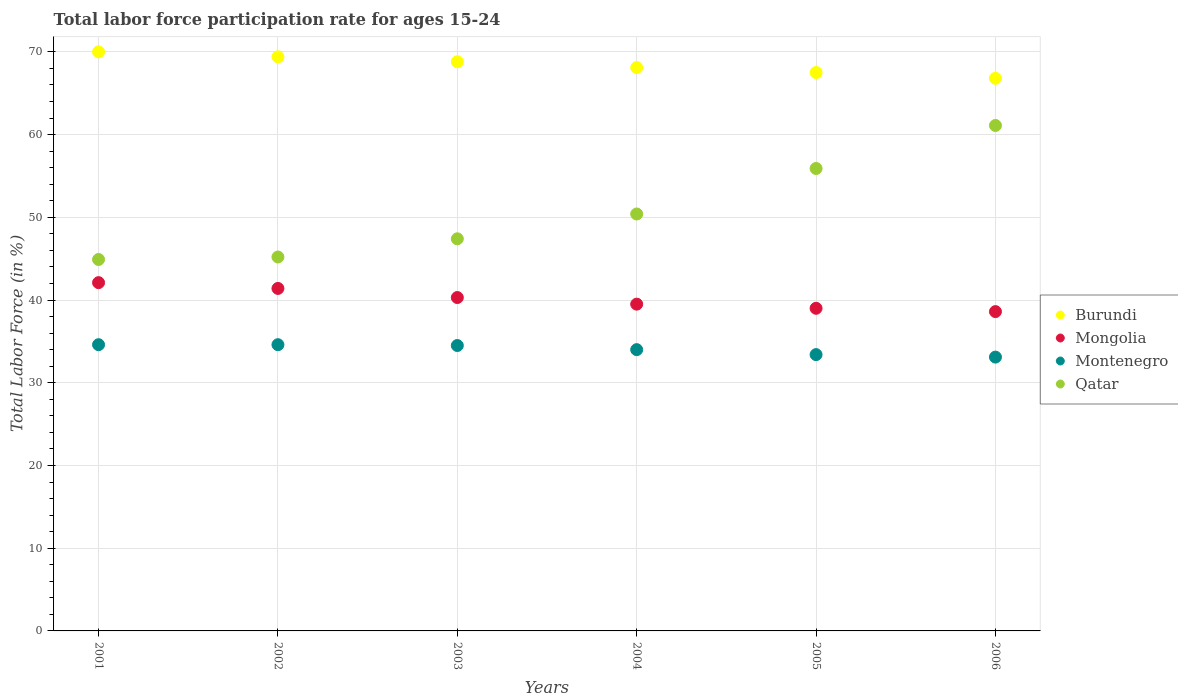How many different coloured dotlines are there?
Provide a succinct answer. 4. Across all years, what is the maximum labor force participation rate in Mongolia?
Keep it short and to the point. 42.1. Across all years, what is the minimum labor force participation rate in Qatar?
Your answer should be very brief. 44.9. What is the total labor force participation rate in Burundi in the graph?
Make the answer very short. 410.6. What is the difference between the labor force participation rate in Burundi in 2003 and that in 2004?
Keep it short and to the point. 0.7. What is the difference between the labor force participation rate in Burundi in 2003 and the labor force participation rate in Qatar in 2005?
Provide a short and direct response. 12.9. What is the average labor force participation rate in Montenegro per year?
Make the answer very short. 34.03. In the year 2005, what is the difference between the labor force participation rate in Qatar and labor force participation rate in Burundi?
Ensure brevity in your answer.  -11.6. What is the ratio of the labor force participation rate in Burundi in 2001 to that in 2005?
Ensure brevity in your answer.  1.04. Is the labor force participation rate in Montenegro in 2002 less than that in 2004?
Provide a succinct answer. No. What is the difference between the highest and the second highest labor force participation rate in Mongolia?
Provide a short and direct response. 0.7. In how many years, is the labor force participation rate in Mongolia greater than the average labor force participation rate in Mongolia taken over all years?
Provide a succinct answer. 3. Is the sum of the labor force participation rate in Mongolia in 2002 and 2005 greater than the maximum labor force participation rate in Qatar across all years?
Your response must be concise. Yes. Is the labor force participation rate in Qatar strictly greater than the labor force participation rate in Montenegro over the years?
Your response must be concise. Yes. How many years are there in the graph?
Give a very brief answer. 6. Are the values on the major ticks of Y-axis written in scientific E-notation?
Keep it short and to the point. No. Does the graph contain grids?
Keep it short and to the point. Yes. What is the title of the graph?
Ensure brevity in your answer.  Total labor force participation rate for ages 15-24. Does "Uzbekistan" appear as one of the legend labels in the graph?
Your response must be concise. No. What is the label or title of the X-axis?
Make the answer very short. Years. What is the Total Labor Force (in %) in Mongolia in 2001?
Make the answer very short. 42.1. What is the Total Labor Force (in %) of Montenegro in 2001?
Your response must be concise. 34.6. What is the Total Labor Force (in %) of Qatar in 2001?
Your response must be concise. 44.9. What is the Total Labor Force (in %) of Burundi in 2002?
Offer a terse response. 69.4. What is the Total Labor Force (in %) in Mongolia in 2002?
Your response must be concise. 41.4. What is the Total Labor Force (in %) in Montenegro in 2002?
Your answer should be compact. 34.6. What is the Total Labor Force (in %) in Qatar in 2002?
Give a very brief answer. 45.2. What is the Total Labor Force (in %) of Burundi in 2003?
Keep it short and to the point. 68.8. What is the Total Labor Force (in %) of Mongolia in 2003?
Your answer should be compact. 40.3. What is the Total Labor Force (in %) in Montenegro in 2003?
Offer a very short reply. 34.5. What is the Total Labor Force (in %) in Qatar in 2003?
Offer a very short reply. 47.4. What is the Total Labor Force (in %) in Burundi in 2004?
Offer a very short reply. 68.1. What is the Total Labor Force (in %) of Mongolia in 2004?
Your response must be concise. 39.5. What is the Total Labor Force (in %) in Montenegro in 2004?
Provide a short and direct response. 34. What is the Total Labor Force (in %) in Qatar in 2004?
Offer a terse response. 50.4. What is the Total Labor Force (in %) in Burundi in 2005?
Your response must be concise. 67.5. What is the Total Labor Force (in %) in Mongolia in 2005?
Your answer should be very brief. 39. What is the Total Labor Force (in %) of Montenegro in 2005?
Your answer should be very brief. 33.4. What is the Total Labor Force (in %) of Qatar in 2005?
Provide a succinct answer. 55.9. What is the Total Labor Force (in %) of Burundi in 2006?
Provide a succinct answer. 66.8. What is the Total Labor Force (in %) in Mongolia in 2006?
Keep it short and to the point. 38.6. What is the Total Labor Force (in %) in Montenegro in 2006?
Keep it short and to the point. 33.1. What is the Total Labor Force (in %) in Qatar in 2006?
Your response must be concise. 61.1. Across all years, what is the maximum Total Labor Force (in %) in Mongolia?
Your answer should be compact. 42.1. Across all years, what is the maximum Total Labor Force (in %) of Montenegro?
Keep it short and to the point. 34.6. Across all years, what is the maximum Total Labor Force (in %) of Qatar?
Give a very brief answer. 61.1. Across all years, what is the minimum Total Labor Force (in %) of Burundi?
Your response must be concise. 66.8. Across all years, what is the minimum Total Labor Force (in %) in Mongolia?
Keep it short and to the point. 38.6. Across all years, what is the minimum Total Labor Force (in %) of Montenegro?
Your answer should be very brief. 33.1. Across all years, what is the minimum Total Labor Force (in %) in Qatar?
Give a very brief answer. 44.9. What is the total Total Labor Force (in %) in Burundi in the graph?
Your answer should be very brief. 410.6. What is the total Total Labor Force (in %) in Mongolia in the graph?
Ensure brevity in your answer.  240.9. What is the total Total Labor Force (in %) in Montenegro in the graph?
Your response must be concise. 204.2. What is the total Total Labor Force (in %) in Qatar in the graph?
Offer a terse response. 304.9. What is the difference between the Total Labor Force (in %) of Qatar in 2001 and that in 2002?
Your answer should be very brief. -0.3. What is the difference between the Total Labor Force (in %) in Montenegro in 2001 and that in 2003?
Make the answer very short. 0.1. What is the difference between the Total Labor Force (in %) of Burundi in 2001 and that in 2004?
Your response must be concise. 1.9. What is the difference between the Total Labor Force (in %) in Mongolia in 2001 and that in 2004?
Your answer should be compact. 2.6. What is the difference between the Total Labor Force (in %) in Qatar in 2001 and that in 2004?
Ensure brevity in your answer.  -5.5. What is the difference between the Total Labor Force (in %) of Mongolia in 2001 and that in 2005?
Provide a succinct answer. 3.1. What is the difference between the Total Labor Force (in %) of Montenegro in 2001 and that in 2005?
Keep it short and to the point. 1.2. What is the difference between the Total Labor Force (in %) of Qatar in 2001 and that in 2005?
Provide a short and direct response. -11. What is the difference between the Total Labor Force (in %) in Burundi in 2001 and that in 2006?
Provide a succinct answer. 3.2. What is the difference between the Total Labor Force (in %) of Qatar in 2001 and that in 2006?
Give a very brief answer. -16.2. What is the difference between the Total Labor Force (in %) of Montenegro in 2002 and that in 2003?
Your response must be concise. 0.1. What is the difference between the Total Labor Force (in %) in Qatar in 2002 and that in 2003?
Your response must be concise. -2.2. What is the difference between the Total Labor Force (in %) of Montenegro in 2002 and that in 2004?
Ensure brevity in your answer.  0.6. What is the difference between the Total Labor Force (in %) of Burundi in 2002 and that in 2005?
Provide a short and direct response. 1.9. What is the difference between the Total Labor Force (in %) of Montenegro in 2002 and that in 2005?
Your answer should be very brief. 1.2. What is the difference between the Total Labor Force (in %) in Qatar in 2002 and that in 2005?
Your answer should be very brief. -10.7. What is the difference between the Total Labor Force (in %) in Burundi in 2002 and that in 2006?
Your answer should be compact. 2.6. What is the difference between the Total Labor Force (in %) in Mongolia in 2002 and that in 2006?
Give a very brief answer. 2.8. What is the difference between the Total Labor Force (in %) of Montenegro in 2002 and that in 2006?
Give a very brief answer. 1.5. What is the difference between the Total Labor Force (in %) in Qatar in 2002 and that in 2006?
Offer a very short reply. -15.9. What is the difference between the Total Labor Force (in %) in Mongolia in 2003 and that in 2004?
Keep it short and to the point. 0.8. What is the difference between the Total Labor Force (in %) of Montenegro in 2003 and that in 2004?
Offer a terse response. 0.5. What is the difference between the Total Labor Force (in %) in Qatar in 2003 and that in 2004?
Give a very brief answer. -3. What is the difference between the Total Labor Force (in %) in Mongolia in 2003 and that in 2005?
Your answer should be compact. 1.3. What is the difference between the Total Labor Force (in %) of Montenegro in 2003 and that in 2005?
Give a very brief answer. 1.1. What is the difference between the Total Labor Force (in %) in Qatar in 2003 and that in 2005?
Provide a short and direct response. -8.5. What is the difference between the Total Labor Force (in %) of Burundi in 2003 and that in 2006?
Offer a very short reply. 2. What is the difference between the Total Labor Force (in %) of Qatar in 2003 and that in 2006?
Your response must be concise. -13.7. What is the difference between the Total Labor Force (in %) of Mongolia in 2004 and that in 2005?
Keep it short and to the point. 0.5. What is the difference between the Total Labor Force (in %) in Montenegro in 2004 and that in 2005?
Your response must be concise. 0.6. What is the difference between the Total Labor Force (in %) in Qatar in 2004 and that in 2005?
Provide a succinct answer. -5.5. What is the difference between the Total Labor Force (in %) of Burundi in 2004 and that in 2006?
Keep it short and to the point. 1.3. What is the difference between the Total Labor Force (in %) in Mongolia in 2004 and that in 2006?
Your response must be concise. 0.9. What is the difference between the Total Labor Force (in %) in Montenegro in 2004 and that in 2006?
Provide a short and direct response. 0.9. What is the difference between the Total Labor Force (in %) of Qatar in 2004 and that in 2006?
Keep it short and to the point. -10.7. What is the difference between the Total Labor Force (in %) in Mongolia in 2005 and that in 2006?
Make the answer very short. 0.4. What is the difference between the Total Labor Force (in %) of Burundi in 2001 and the Total Labor Force (in %) of Mongolia in 2002?
Offer a very short reply. 28.6. What is the difference between the Total Labor Force (in %) in Burundi in 2001 and the Total Labor Force (in %) in Montenegro in 2002?
Provide a short and direct response. 35.4. What is the difference between the Total Labor Force (in %) in Burundi in 2001 and the Total Labor Force (in %) in Qatar in 2002?
Provide a succinct answer. 24.8. What is the difference between the Total Labor Force (in %) in Burundi in 2001 and the Total Labor Force (in %) in Mongolia in 2003?
Give a very brief answer. 29.7. What is the difference between the Total Labor Force (in %) of Burundi in 2001 and the Total Labor Force (in %) of Montenegro in 2003?
Give a very brief answer. 35.5. What is the difference between the Total Labor Force (in %) in Burundi in 2001 and the Total Labor Force (in %) in Qatar in 2003?
Make the answer very short. 22.6. What is the difference between the Total Labor Force (in %) of Burundi in 2001 and the Total Labor Force (in %) of Mongolia in 2004?
Make the answer very short. 30.5. What is the difference between the Total Labor Force (in %) of Burundi in 2001 and the Total Labor Force (in %) of Qatar in 2004?
Ensure brevity in your answer.  19.6. What is the difference between the Total Labor Force (in %) of Mongolia in 2001 and the Total Labor Force (in %) of Qatar in 2004?
Your response must be concise. -8.3. What is the difference between the Total Labor Force (in %) in Montenegro in 2001 and the Total Labor Force (in %) in Qatar in 2004?
Provide a short and direct response. -15.8. What is the difference between the Total Labor Force (in %) of Burundi in 2001 and the Total Labor Force (in %) of Montenegro in 2005?
Your answer should be compact. 36.6. What is the difference between the Total Labor Force (in %) of Montenegro in 2001 and the Total Labor Force (in %) of Qatar in 2005?
Give a very brief answer. -21.3. What is the difference between the Total Labor Force (in %) in Burundi in 2001 and the Total Labor Force (in %) in Mongolia in 2006?
Provide a succinct answer. 31.4. What is the difference between the Total Labor Force (in %) in Burundi in 2001 and the Total Labor Force (in %) in Montenegro in 2006?
Provide a short and direct response. 36.9. What is the difference between the Total Labor Force (in %) of Mongolia in 2001 and the Total Labor Force (in %) of Montenegro in 2006?
Provide a succinct answer. 9. What is the difference between the Total Labor Force (in %) of Mongolia in 2001 and the Total Labor Force (in %) of Qatar in 2006?
Give a very brief answer. -19. What is the difference between the Total Labor Force (in %) of Montenegro in 2001 and the Total Labor Force (in %) of Qatar in 2006?
Make the answer very short. -26.5. What is the difference between the Total Labor Force (in %) of Burundi in 2002 and the Total Labor Force (in %) of Mongolia in 2003?
Your answer should be very brief. 29.1. What is the difference between the Total Labor Force (in %) of Burundi in 2002 and the Total Labor Force (in %) of Montenegro in 2003?
Your answer should be very brief. 34.9. What is the difference between the Total Labor Force (in %) in Mongolia in 2002 and the Total Labor Force (in %) in Qatar in 2003?
Offer a very short reply. -6. What is the difference between the Total Labor Force (in %) in Burundi in 2002 and the Total Labor Force (in %) in Mongolia in 2004?
Provide a short and direct response. 29.9. What is the difference between the Total Labor Force (in %) in Burundi in 2002 and the Total Labor Force (in %) in Montenegro in 2004?
Offer a terse response. 35.4. What is the difference between the Total Labor Force (in %) of Mongolia in 2002 and the Total Labor Force (in %) of Montenegro in 2004?
Your answer should be very brief. 7.4. What is the difference between the Total Labor Force (in %) in Montenegro in 2002 and the Total Labor Force (in %) in Qatar in 2004?
Your response must be concise. -15.8. What is the difference between the Total Labor Force (in %) in Burundi in 2002 and the Total Labor Force (in %) in Mongolia in 2005?
Your response must be concise. 30.4. What is the difference between the Total Labor Force (in %) in Burundi in 2002 and the Total Labor Force (in %) in Montenegro in 2005?
Give a very brief answer. 36. What is the difference between the Total Labor Force (in %) in Burundi in 2002 and the Total Labor Force (in %) in Qatar in 2005?
Offer a very short reply. 13.5. What is the difference between the Total Labor Force (in %) of Mongolia in 2002 and the Total Labor Force (in %) of Montenegro in 2005?
Make the answer very short. 8. What is the difference between the Total Labor Force (in %) of Mongolia in 2002 and the Total Labor Force (in %) of Qatar in 2005?
Your response must be concise. -14.5. What is the difference between the Total Labor Force (in %) of Montenegro in 2002 and the Total Labor Force (in %) of Qatar in 2005?
Your answer should be very brief. -21.3. What is the difference between the Total Labor Force (in %) in Burundi in 2002 and the Total Labor Force (in %) in Mongolia in 2006?
Offer a very short reply. 30.8. What is the difference between the Total Labor Force (in %) in Burundi in 2002 and the Total Labor Force (in %) in Montenegro in 2006?
Ensure brevity in your answer.  36.3. What is the difference between the Total Labor Force (in %) in Burundi in 2002 and the Total Labor Force (in %) in Qatar in 2006?
Your response must be concise. 8.3. What is the difference between the Total Labor Force (in %) of Mongolia in 2002 and the Total Labor Force (in %) of Montenegro in 2006?
Provide a succinct answer. 8.3. What is the difference between the Total Labor Force (in %) in Mongolia in 2002 and the Total Labor Force (in %) in Qatar in 2006?
Provide a short and direct response. -19.7. What is the difference between the Total Labor Force (in %) of Montenegro in 2002 and the Total Labor Force (in %) of Qatar in 2006?
Offer a terse response. -26.5. What is the difference between the Total Labor Force (in %) in Burundi in 2003 and the Total Labor Force (in %) in Mongolia in 2004?
Your answer should be compact. 29.3. What is the difference between the Total Labor Force (in %) of Burundi in 2003 and the Total Labor Force (in %) of Montenegro in 2004?
Give a very brief answer. 34.8. What is the difference between the Total Labor Force (in %) of Burundi in 2003 and the Total Labor Force (in %) of Qatar in 2004?
Offer a very short reply. 18.4. What is the difference between the Total Labor Force (in %) of Mongolia in 2003 and the Total Labor Force (in %) of Montenegro in 2004?
Keep it short and to the point. 6.3. What is the difference between the Total Labor Force (in %) in Montenegro in 2003 and the Total Labor Force (in %) in Qatar in 2004?
Give a very brief answer. -15.9. What is the difference between the Total Labor Force (in %) in Burundi in 2003 and the Total Labor Force (in %) in Mongolia in 2005?
Your response must be concise. 29.8. What is the difference between the Total Labor Force (in %) of Burundi in 2003 and the Total Labor Force (in %) of Montenegro in 2005?
Offer a very short reply. 35.4. What is the difference between the Total Labor Force (in %) of Burundi in 2003 and the Total Labor Force (in %) of Qatar in 2005?
Provide a succinct answer. 12.9. What is the difference between the Total Labor Force (in %) in Mongolia in 2003 and the Total Labor Force (in %) in Qatar in 2005?
Give a very brief answer. -15.6. What is the difference between the Total Labor Force (in %) of Montenegro in 2003 and the Total Labor Force (in %) of Qatar in 2005?
Your answer should be compact. -21.4. What is the difference between the Total Labor Force (in %) of Burundi in 2003 and the Total Labor Force (in %) of Mongolia in 2006?
Provide a succinct answer. 30.2. What is the difference between the Total Labor Force (in %) of Burundi in 2003 and the Total Labor Force (in %) of Montenegro in 2006?
Give a very brief answer. 35.7. What is the difference between the Total Labor Force (in %) in Burundi in 2003 and the Total Labor Force (in %) in Qatar in 2006?
Provide a succinct answer. 7.7. What is the difference between the Total Labor Force (in %) of Mongolia in 2003 and the Total Labor Force (in %) of Qatar in 2006?
Your response must be concise. -20.8. What is the difference between the Total Labor Force (in %) in Montenegro in 2003 and the Total Labor Force (in %) in Qatar in 2006?
Your response must be concise. -26.6. What is the difference between the Total Labor Force (in %) in Burundi in 2004 and the Total Labor Force (in %) in Mongolia in 2005?
Keep it short and to the point. 29.1. What is the difference between the Total Labor Force (in %) in Burundi in 2004 and the Total Labor Force (in %) in Montenegro in 2005?
Keep it short and to the point. 34.7. What is the difference between the Total Labor Force (in %) in Burundi in 2004 and the Total Labor Force (in %) in Qatar in 2005?
Offer a terse response. 12.2. What is the difference between the Total Labor Force (in %) in Mongolia in 2004 and the Total Labor Force (in %) in Qatar in 2005?
Offer a terse response. -16.4. What is the difference between the Total Labor Force (in %) in Montenegro in 2004 and the Total Labor Force (in %) in Qatar in 2005?
Offer a terse response. -21.9. What is the difference between the Total Labor Force (in %) of Burundi in 2004 and the Total Labor Force (in %) of Mongolia in 2006?
Ensure brevity in your answer.  29.5. What is the difference between the Total Labor Force (in %) in Burundi in 2004 and the Total Labor Force (in %) in Qatar in 2006?
Your answer should be compact. 7. What is the difference between the Total Labor Force (in %) in Mongolia in 2004 and the Total Labor Force (in %) in Qatar in 2006?
Keep it short and to the point. -21.6. What is the difference between the Total Labor Force (in %) of Montenegro in 2004 and the Total Labor Force (in %) of Qatar in 2006?
Your answer should be compact. -27.1. What is the difference between the Total Labor Force (in %) of Burundi in 2005 and the Total Labor Force (in %) of Mongolia in 2006?
Keep it short and to the point. 28.9. What is the difference between the Total Labor Force (in %) of Burundi in 2005 and the Total Labor Force (in %) of Montenegro in 2006?
Make the answer very short. 34.4. What is the difference between the Total Labor Force (in %) of Mongolia in 2005 and the Total Labor Force (in %) of Montenegro in 2006?
Your response must be concise. 5.9. What is the difference between the Total Labor Force (in %) in Mongolia in 2005 and the Total Labor Force (in %) in Qatar in 2006?
Provide a succinct answer. -22.1. What is the difference between the Total Labor Force (in %) in Montenegro in 2005 and the Total Labor Force (in %) in Qatar in 2006?
Keep it short and to the point. -27.7. What is the average Total Labor Force (in %) of Burundi per year?
Offer a terse response. 68.43. What is the average Total Labor Force (in %) in Mongolia per year?
Provide a short and direct response. 40.15. What is the average Total Labor Force (in %) of Montenegro per year?
Offer a terse response. 34.03. What is the average Total Labor Force (in %) in Qatar per year?
Offer a very short reply. 50.82. In the year 2001, what is the difference between the Total Labor Force (in %) in Burundi and Total Labor Force (in %) in Mongolia?
Your answer should be very brief. 27.9. In the year 2001, what is the difference between the Total Labor Force (in %) of Burundi and Total Labor Force (in %) of Montenegro?
Give a very brief answer. 35.4. In the year 2001, what is the difference between the Total Labor Force (in %) of Burundi and Total Labor Force (in %) of Qatar?
Your answer should be compact. 25.1. In the year 2001, what is the difference between the Total Labor Force (in %) of Mongolia and Total Labor Force (in %) of Qatar?
Offer a very short reply. -2.8. In the year 2002, what is the difference between the Total Labor Force (in %) of Burundi and Total Labor Force (in %) of Mongolia?
Give a very brief answer. 28. In the year 2002, what is the difference between the Total Labor Force (in %) in Burundi and Total Labor Force (in %) in Montenegro?
Offer a very short reply. 34.8. In the year 2002, what is the difference between the Total Labor Force (in %) of Burundi and Total Labor Force (in %) of Qatar?
Your answer should be compact. 24.2. In the year 2002, what is the difference between the Total Labor Force (in %) in Mongolia and Total Labor Force (in %) in Montenegro?
Provide a succinct answer. 6.8. In the year 2003, what is the difference between the Total Labor Force (in %) in Burundi and Total Labor Force (in %) in Mongolia?
Provide a short and direct response. 28.5. In the year 2003, what is the difference between the Total Labor Force (in %) of Burundi and Total Labor Force (in %) of Montenegro?
Ensure brevity in your answer.  34.3. In the year 2003, what is the difference between the Total Labor Force (in %) of Burundi and Total Labor Force (in %) of Qatar?
Offer a very short reply. 21.4. In the year 2003, what is the difference between the Total Labor Force (in %) of Mongolia and Total Labor Force (in %) of Qatar?
Your response must be concise. -7.1. In the year 2004, what is the difference between the Total Labor Force (in %) in Burundi and Total Labor Force (in %) in Mongolia?
Keep it short and to the point. 28.6. In the year 2004, what is the difference between the Total Labor Force (in %) of Burundi and Total Labor Force (in %) of Montenegro?
Your answer should be very brief. 34.1. In the year 2004, what is the difference between the Total Labor Force (in %) of Mongolia and Total Labor Force (in %) of Qatar?
Make the answer very short. -10.9. In the year 2004, what is the difference between the Total Labor Force (in %) in Montenegro and Total Labor Force (in %) in Qatar?
Your answer should be very brief. -16.4. In the year 2005, what is the difference between the Total Labor Force (in %) of Burundi and Total Labor Force (in %) of Mongolia?
Give a very brief answer. 28.5. In the year 2005, what is the difference between the Total Labor Force (in %) of Burundi and Total Labor Force (in %) of Montenegro?
Give a very brief answer. 34.1. In the year 2005, what is the difference between the Total Labor Force (in %) in Mongolia and Total Labor Force (in %) in Montenegro?
Your answer should be compact. 5.6. In the year 2005, what is the difference between the Total Labor Force (in %) in Mongolia and Total Labor Force (in %) in Qatar?
Ensure brevity in your answer.  -16.9. In the year 2005, what is the difference between the Total Labor Force (in %) in Montenegro and Total Labor Force (in %) in Qatar?
Give a very brief answer. -22.5. In the year 2006, what is the difference between the Total Labor Force (in %) in Burundi and Total Labor Force (in %) in Mongolia?
Provide a succinct answer. 28.2. In the year 2006, what is the difference between the Total Labor Force (in %) in Burundi and Total Labor Force (in %) in Montenegro?
Ensure brevity in your answer.  33.7. In the year 2006, what is the difference between the Total Labor Force (in %) in Mongolia and Total Labor Force (in %) in Montenegro?
Provide a short and direct response. 5.5. In the year 2006, what is the difference between the Total Labor Force (in %) of Mongolia and Total Labor Force (in %) of Qatar?
Make the answer very short. -22.5. In the year 2006, what is the difference between the Total Labor Force (in %) of Montenegro and Total Labor Force (in %) of Qatar?
Offer a terse response. -28. What is the ratio of the Total Labor Force (in %) of Burundi in 2001 to that in 2002?
Your response must be concise. 1.01. What is the ratio of the Total Labor Force (in %) of Mongolia in 2001 to that in 2002?
Provide a short and direct response. 1.02. What is the ratio of the Total Labor Force (in %) of Burundi in 2001 to that in 2003?
Ensure brevity in your answer.  1.02. What is the ratio of the Total Labor Force (in %) in Mongolia in 2001 to that in 2003?
Your answer should be very brief. 1.04. What is the ratio of the Total Labor Force (in %) in Montenegro in 2001 to that in 2003?
Your answer should be compact. 1. What is the ratio of the Total Labor Force (in %) of Qatar in 2001 to that in 2003?
Offer a very short reply. 0.95. What is the ratio of the Total Labor Force (in %) of Burundi in 2001 to that in 2004?
Your answer should be very brief. 1.03. What is the ratio of the Total Labor Force (in %) in Mongolia in 2001 to that in 2004?
Provide a succinct answer. 1.07. What is the ratio of the Total Labor Force (in %) of Montenegro in 2001 to that in 2004?
Offer a very short reply. 1.02. What is the ratio of the Total Labor Force (in %) of Qatar in 2001 to that in 2004?
Offer a very short reply. 0.89. What is the ratio of the Total Labor Force (in %) of Burundi in 2001 to that in 2005?
Offer a very short reply. 1.04. What is the ratio of the Total Labor Force (in %) in Mongolia in 2001 to that in 2005?
Your response must be concise. 1.08. What is the ratio of the Total Labor Force (in %) in Montenegro in 2001 to that in 2005?
Offer a terse response. 1.04. What is the ratio of the Total Labor Force (in %) in Qatar in 2001 to that in 2005?
Your answer should be very brief. 0.8. What is the ratio of the Total Labor Force (in %) of Burundi in 2001 to that in 2006?
Your answer should be compact. 1.05. What is the ratio of the Total Labor Force (in %) in Mongolia in 2001 to that in 2006?
Provide a short and direct response. 1.09. What is the ratio of the Total Labor Force (in %) of Montenegro in 2001 to that in 2006?
Your answer should be compact. 1.05. What is the ratio of the Total Labor Force (in %) of Qatar in 2001 to that in 2006?
Make the answer very short. 0.73. What is the ratio of the Total Labor Force (in %) in Burundi in 2002 to that in 2003?
Offer a terse response. 1.01. What is the ratio of the Total Labor Force (in %) in Mongolia in 2002 to that in 2003?
Offer a terse response. 1.03. What is the ratio of the Total Labor Force (in %) of Montenegro in 2002 to that in 2003?
Ensure brevity in your answer.  1. What is the ratio of the Total Labor Force (in %) of Qatar in 2002 to that in 2003?
Your answer should be very brief. 0.95. What is the ratio of the Total Labor Force (in %) of Burundi in 2002 to that in 2004?
Provide a succinct answer. 1.02. What is the ratio of the Total Labor Force (in %) in Mongolia in 2002 to that in 2004?
Ensure brevity in your answer.  1.05. What is the ratio of the Total Labor Force (in %) in Montenegro in 2002 to that in 2004?
Provide a succinct answer. 1.02. What is the ratio of the Total Labor Force (in %) in Qatar in 2002 to that in 2004?
Provide a succinct answer. 0.9. What is the ratio of the Total Labor Force (in %) in Burundi in 2002 to that in 2005?
Provide a short and direct response. 1.03. What is the ratio of the Total Labor Force (in %) in Mongolia in 2002 to that in 2005?
Offer a very short reply. 1.06. What is the ratio of the Total Labor Force (in %) in Montenegro in 2002 to that in 2005?
Offer a very short reply. 1.04. What is the ratio of the Total Labor Force (in %) of Qatar in 2002 to that in 2005?
Offer a very short reply. 0.81. What is the ratio of the Total Labor Force (in %) of Burundi in 2002 to that in 2006?
Ensure brevity in your answer.  1.04. What is the ratio of the Total Labor Force (in %) of Mongolia in 2002 to that in 2006?
Provide a succinct answer. 1.07. What is the ratio of the Total Labor Force (in %) in Montenegro in 2002 to that in 2006?
Provide a short and direct response. 1.05. What is the ratio of the Total Labor Force (in %) in Qatar in 2002 to that in 2006?
Provide a succinct answer. 0.74. What is the ratio of the Total Labor Force (in %) of Burundi in 2003 to that in 2004?
Your answer should be very brief. 1.01. What is the ratio of the Total Labor Force (in %) of Mongolia in 2003 to that in 2004?
Make the answer very short. 1.02. What is the ratio of the Total Labor Force (in %) of Montenegro in 2003 to that in 2004?
Offer a very short reply. 1.01. What is the ratio of the Total Labor Force (in %) of Qatar in 2003 to that in 2004?
Give a very brief answer. 0.94. What is the ratio of the Total Labor Force (in %) in Burundi in 2003 to that in 2005?
Make the answer very short. 1.02. What is the ratio of the Total Labor Force (in %) in Montenegro in 2003 to that in 2005?
Your response must be concise. 1.03. What is the ratio of the Total Labor Force (in %) in Qatar in 2003 to that in 2005?
Provide a short and direct response. 0.85. What is the ratio of the Total Labor Force (in %) in Burundi in 2003 to that in 2006?
Your response must be concise. 1.03. What is the ratio of the Total Labor Force (in %) in Mongolia in 2003 to that in 2006?
Give a very brief answer. 1.04. What is the ratio of the Total Labor Force (in %) of Montenegro in 2003 to that in 2006?
Your response must be concise. 1.04. What is the ratio of the Total Labor Force (in %) of Qatar in 2003 to that in 2006?
Offer a terse response. 0.78. What is the ratio of the Total Labor Force (in %) of Burundi in 2004 to that in 2005?
Offer a very short reply. 1.01. What is the ratio of the Total Labor Force (in %) in Mongolia in 2004 to that in 2005?
Your answer should be compact. 1.01. What is the ratio of the Total Labor Force (in %) of Montenegro in 2004 to that in 2005?
Provide a short and direct response. 1.02. What is the ratio of the Total Labor Force (in %) of Qatar in 2004 to that in 2005?
Keep it short and to the point. 0.9. What is the ratio of the Total Labor Force (in %) of Burundi in 2004 to that in 2006?
Ensure brevity in your answer.  1.02. What is the ratio of the Total Labor Force (in %) in Mongolia in 2004 to that in 2006?
Give a very brief answer. 1.02. What is the ratio of the Total Labor Force (in %) of Montenegro in 2004 to that in 2006?
Your answer should be compact. 1.03. What is the ratio of the Total Labor Force (in %) in Qatar in 2004 to that in 2006?
Offer a very short reply. 0.82. What is the ratio of the Total Labor Force (in %) in Burundi in 2005 to that in 2006?
Provide a succinct answer. 1.01. What is the ratio of the Total Labor Force (in %) in Mongolia in 2005 to that in 2006?
Offer a terse response. 1.01. What is the ratio of the Total Labor Force (in %) in Montenegro in 2005 to that in 2006?
Your answer should be very brief. 1.01. What is the ratio of the Total Labor Force (in %) in Qatar in 2005 to that in 2006?
Give a very brief answer. 0.91. What is the difference between the highest and the second highest Total Labor Force (in %) in Burundi?
Provide a short and direct response. 0.6. What is the difference between the highest and the lowest Total Labor Force (in %) in Mongolia?
Make the answer very short. 3.5. What is the difference between the highest and the lowest Total Labor Force (in %) of Qatar?
Provide a succinct answer. 16.2. 